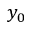Convert formula to latex. <formula><loc_0><loc_0><loc_500><loc_500>y _ { 0 }</formula> 